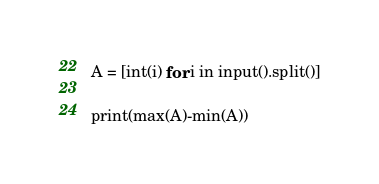Convert code to text. <code><loc_0><loc_0><loc_500><loc_500><_Python_>A = [int(i) for i in input().split()]

print(max(A)-min(A))</code> 